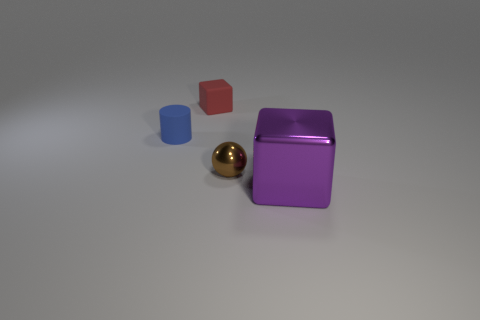Add 1 big yellow matte spheres. How many objects exist? 5 Subtract all cylinders. How many objects are left? 3 Subtract all big gray matte things. Subtract all tiny red rubber things. How many objects are left? 3 Add 3 big things. How many big things are left? 4 Add 4 tiny matte cylinders. How many tiny matte cylinders exist? 5 Subtract 0 yellow cubes. How many objects are left? 4 